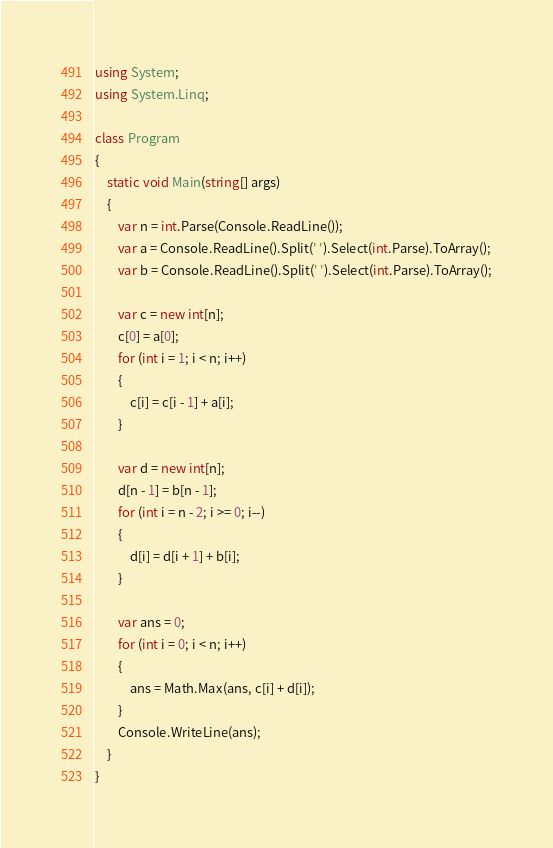Convert code to text. <code><loc_0><loc_0><loc_500><loc_500><_C#_>using System;
using System.Linq;

class Program
{
    static void Main(string[] args)
    {
        var n = int.Parse(Console.ReadLine());
        var a = Console.ReadLine().Split(' ').Select(int.Parse).ToArray();
        var b = Console.ReadLine().Split(' ').Select(int.Parse).ToArray();

        var c = new int[n];
        c[0] = a[0];
        for (int i = 1; i < n; i++)
        {
            c[i] = c[i - 1] + a[i];
        }

        var d = new int[n];
        d[n - 1] = b[n - 1];
        for (int i = n - 2; i >= 0; i--)
        {
            d[i] = d[i + 1] + b[i];
        }

        var ans = 0;
        for (int i = 0; i < n; i++)
        {
            ans = Math.Max(ans, c[i] + d[i]);
        }
        Console.WriteLine(ans);
    }
}
</code> 